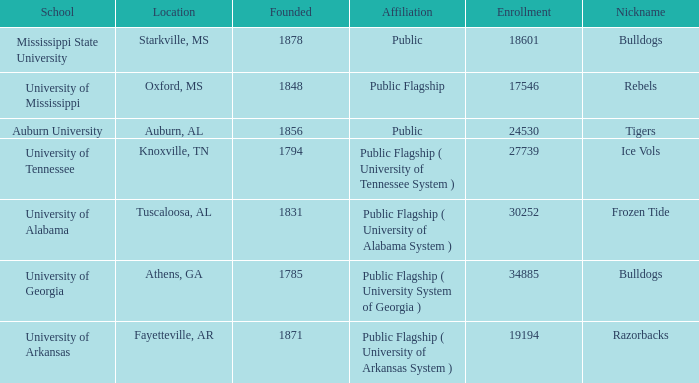What is the maximum enrollment of the schools? 34885.0. 